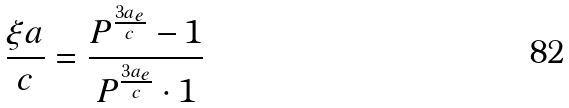<formula> <loc_0><loc_0><loc_500><loc_500>\frac { \xi a } { c } = \frac { P ^ { \frac { 3 a _ { e } } { c } } - 1 } { P ^ { \frac { 3 a _ { e } } { c } } \cdot 1 }</formula> 